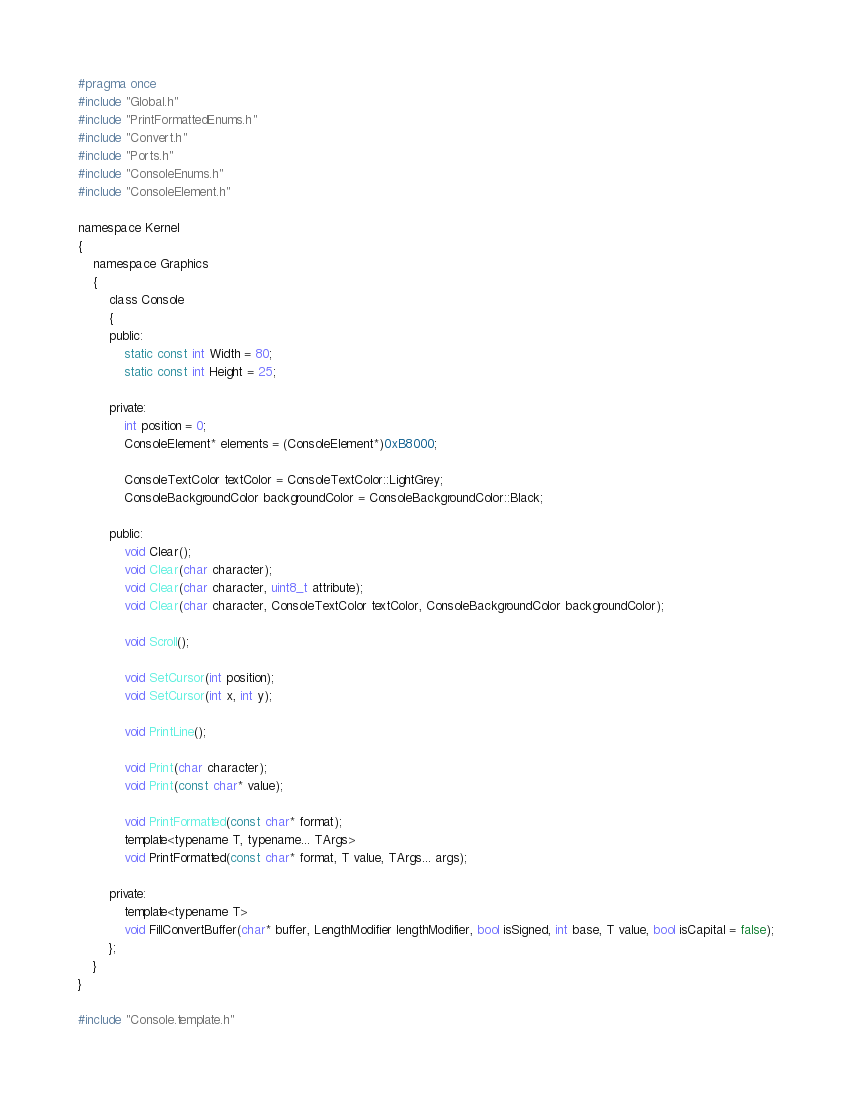Convert code to text. <code><loc_0><loc_0><loc_500><loc_500><_C_>#pragma once
#include "Global.h"
#include "PrintFormattedEnums.h"
#include "Convert.h"
#include "Ports.h"
#include "ConsoleEnums.h"
#include "ConsoleElement.h"

namespace Kernel
{
    namespace Graphics
    {
        class Console
        {
        public:
            static const int Width = 80;
            static const int Height = 25;

        private:
            int position = 0;
            ConsoleElement* elements = (ConsoleElement*)0xB8000;

            ConsoleTextColor textColor = ConsoleTextColor::LightGrey;
            ConsoleBackgroundColor backgroundColor = ConsoleBackgroundColor::Black;

        public:
            void Clear();
            void Clear(char character);
            void Clear(char character, uint8_t attribute);
            void Clear(char character, ConsoleTextColor textColor, ConsoleBackgroundColor backgroundColor);

            void Scroll();

            void SetCursor(int position);
            void SetCursor(int x, int y);

            void PrintLine();

            void Print(char character);
            void Print(const char* value);

            void PrintFormatted(const char* format);
            template<typename T, typename... TArgs>
            void PrintFormatted(const char* format, T value, TArgs... args);

        private:
            template<typename T>
            void FillConvertBuffer(char* buffer, LengthModifier lengthModifier, bool isSigned, int base, T value, bool isCapital = false);
        };
    }
}

#include "Console.template.h"</code> 